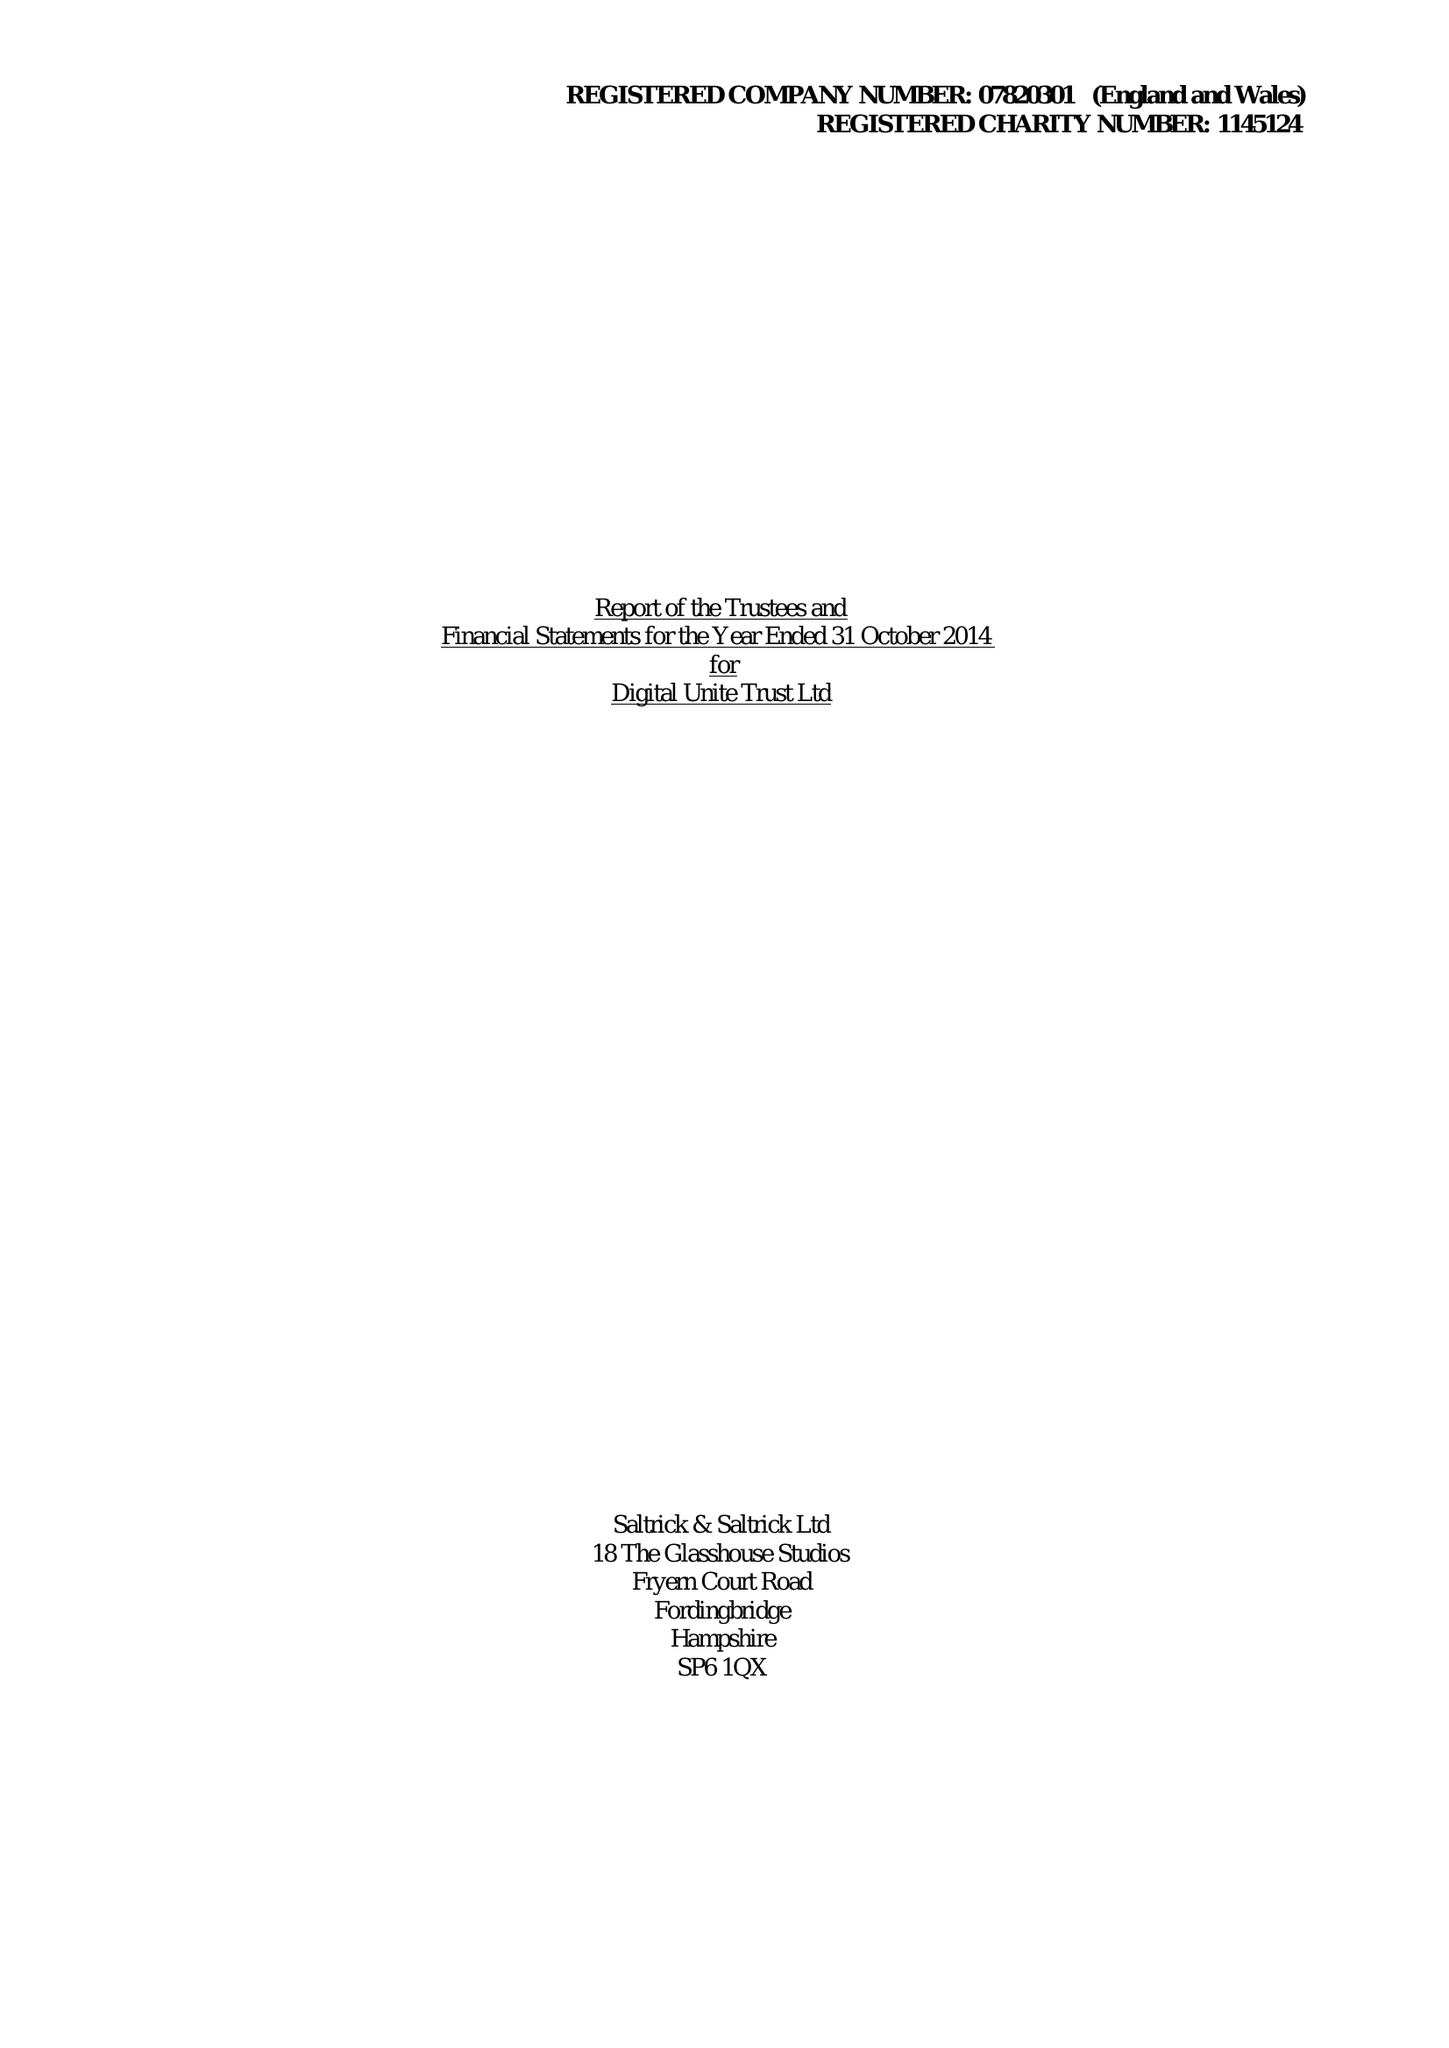What is the value for the charity_name?
Answer the question using a single word or phrase. Digital Unite Trust Ltd. 